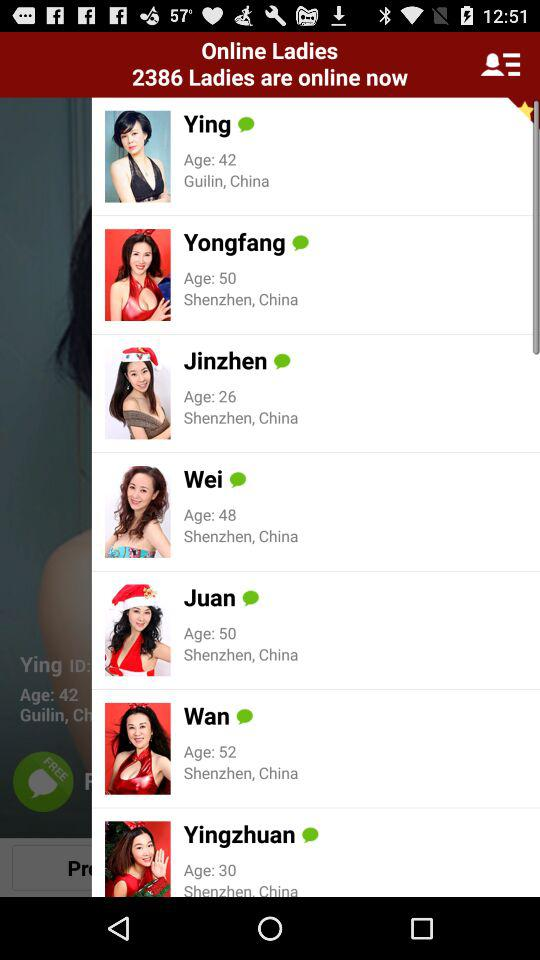What is the location of Ying? The location of Ying is Guilin, China. 